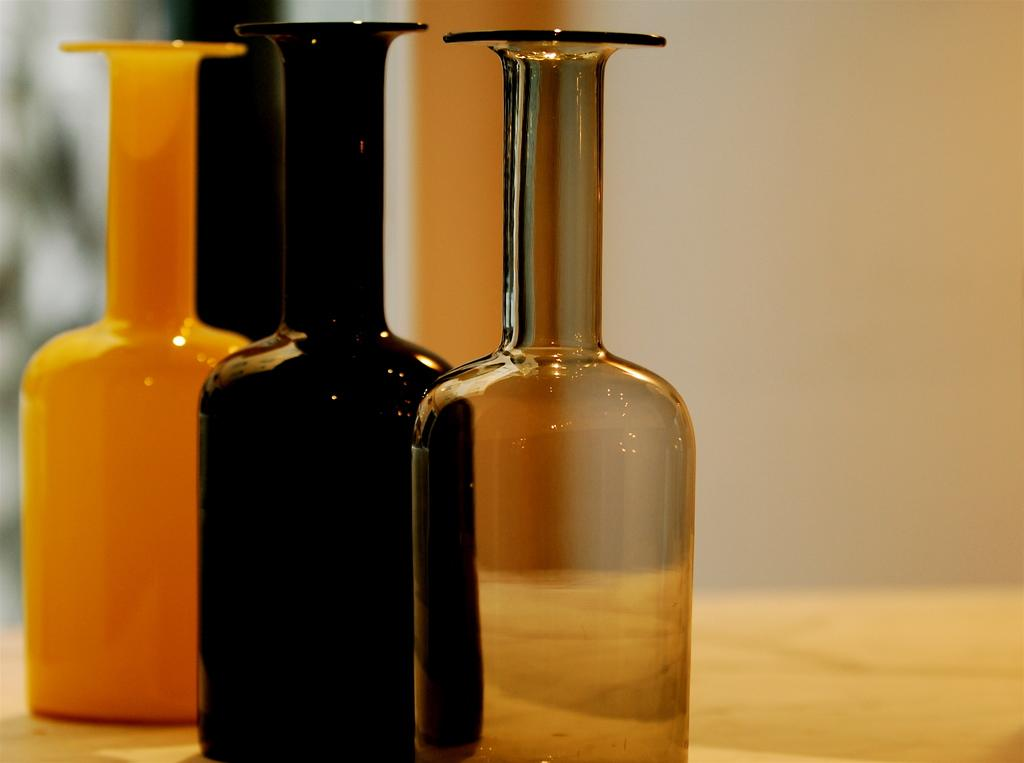How many bottles are on the table in the image? There are three bottles on a table in the image. What else can be seen in the image besides the bottles? There is a wall in the image. What type of apparel is the wall wearing in the image? The wall is not wearing any apparel, as it is a stationary structure and not a living being. 